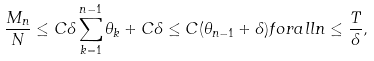<formula> <loc_0><loc_0><loc_500><loc_500>\frac { M _ { n } } { N } \leq C \delta \sum _ { k = 1 } ^ { n - 1 } \theta _ { k } + C \delta \leq C ( \theta _ { n - 1 } + \delta ) f o r a l l n \leq \frac { T } { \delta } ,</formula> 